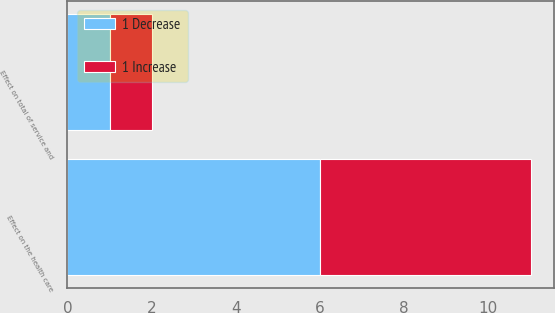Convert chart. <chart><loc_0><loc_0><loc_500><loc_500><stacked_bar_chart><ecel><fcel>Effect on total of service and<fcel>Effect on the health care<nl><fcel>1 Decrease<fcel>1<fcel>6<nl><fcel>1 Increase<fcel>1<fcel>5<nl></chart> 